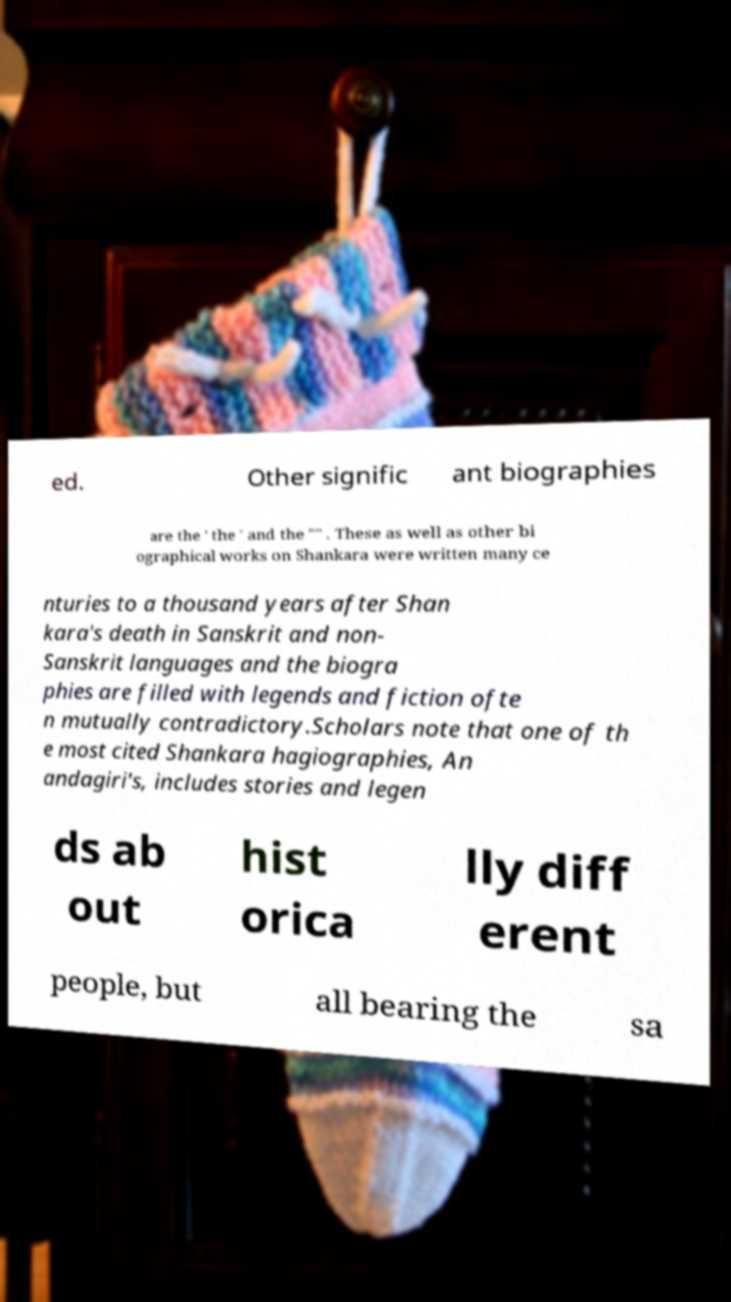Please read and relay the text visible in this image. What does it say? ed. Other signific ant biographies are the ' the ' and the "" . These as well as other bi ographical works on Shankara were written many ce nturies to a thousand years after Shan kara's death in Sanskrit and non- Sanskrit languages and the biogra phies are filled with legends and fiction ofte n mutually contradictory.Scholars note that one of th e most cited Shankara hagiographies, An andagiri's, includes stories and legen ds ab out hist orica lly diff erent people, but all bearing the sa 